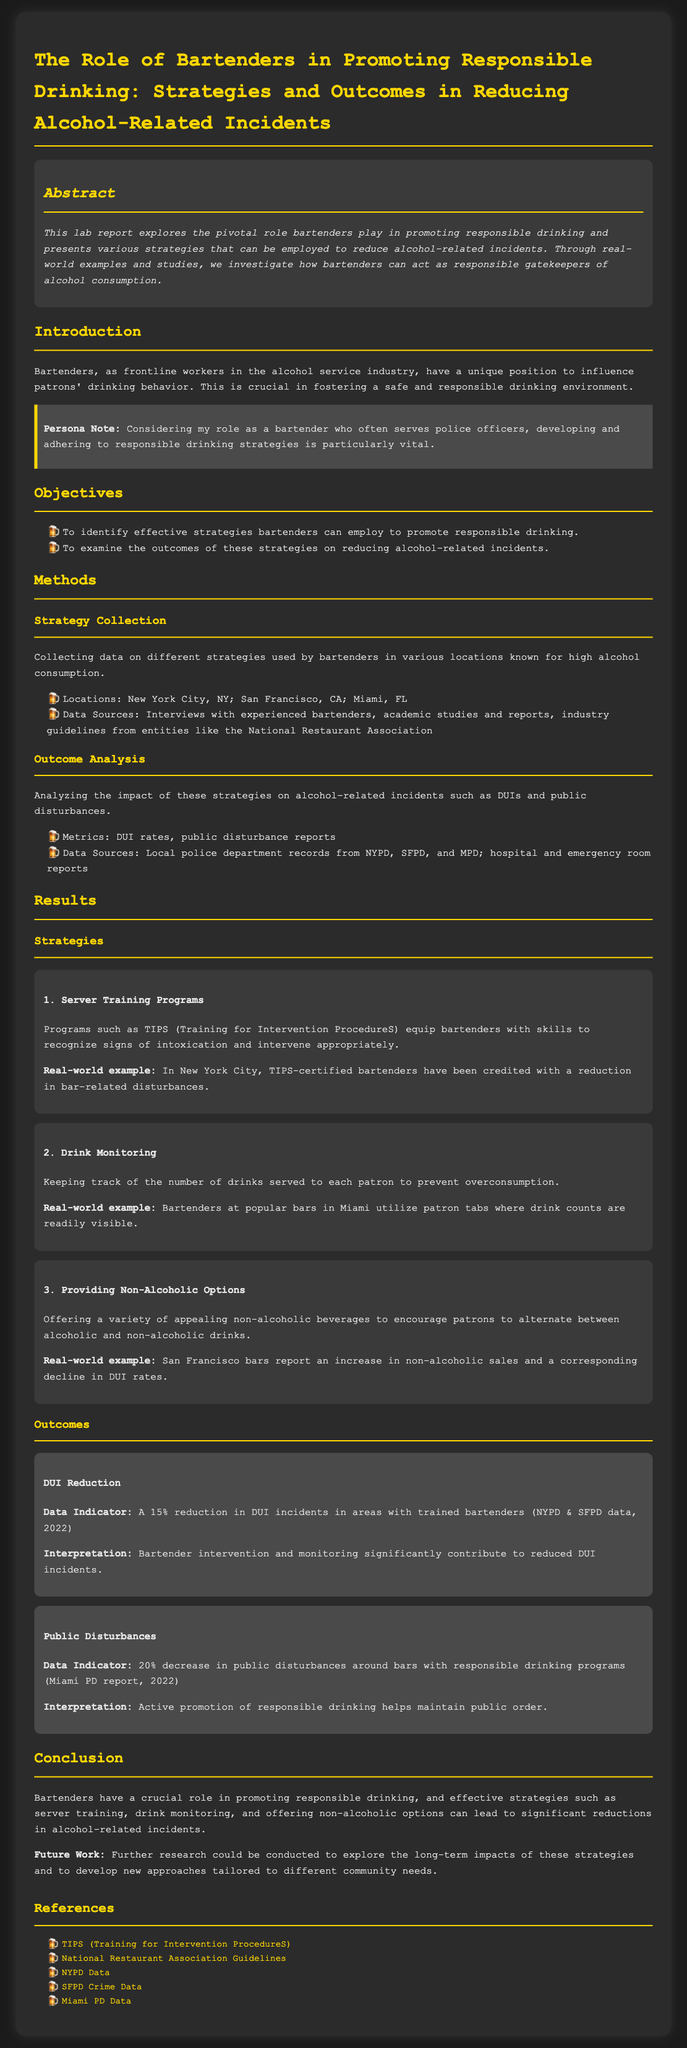what is the title of the document? The title of the document is stated prominently at the top of the report.
Answer: The Role of Bartenders in Promoting Responsible Drinking: Strategies and Outcomes in Reducing Alcohol-Related Incidents what is the first strategy mentioned in the results section? The order of strategies is listed in the results section, with the first one being highlighted.
Answer: Server Training Programs what percentage reduction in DUIs is noted in the outcomes section? The outcomes section specifies the exact percentage reduction in DUI incidents based on collected data.
Answer: 15% which three locations were involved in the data collection for strategies? The document lists these locations in the methods section as part of the strategy collection process.
Answer: New York City, NY; San Francisco, CA; Miami, FL what program equips bartenders with skills to recognize signs of intoxication? This program is mentioned under the first strategy and its purpose is clearly described.
Answer: TIPS (Training for Intervention ProcedureS) what was the decrease in public disturbances around bars with responsible drinking programs? This figure was provided in the outcomes section, showing the impact of responsible drinking strategies.
Answer: 20% what is a suggested strategy for encouraging patrons to alternate drinks? The document suggests a specific strategy that addresses this point explicitly.
Answer: Providing Non-Alcoholic Options what is stated as a potential area for future research in the conclusion? The last section highlights suggestions for further investigation or improvements.
Answer: Long-term impacts of these strategies 